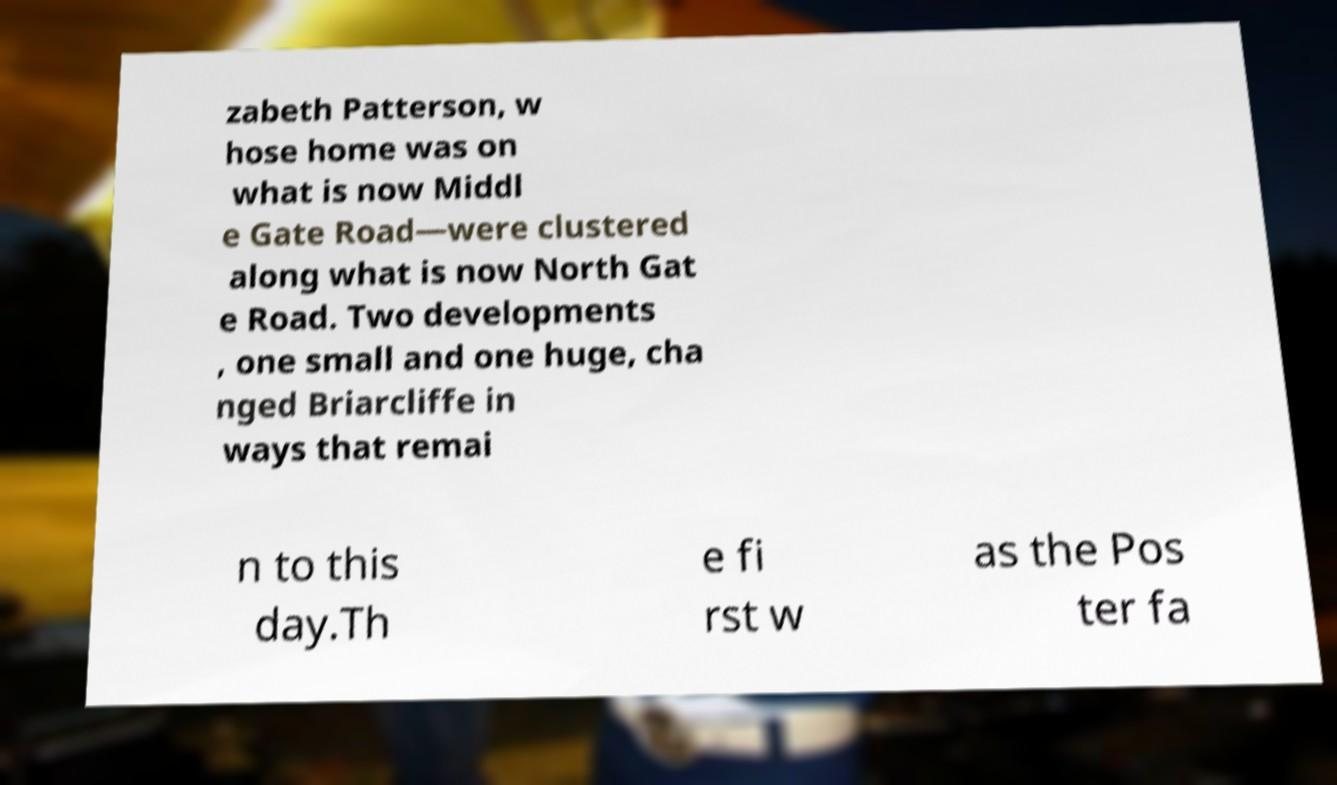What messages or text are displayed in this image? I need them in a readable, typed format. zabeth Patterson, w hose home was on what is now Middl e Gate Road—were clustered along what is now North Gat e Road. Two developments , one small and one huge, cha nged Briarcliffe in ways that remai n to this day.Th e fi rst w as the Pos ter fa 